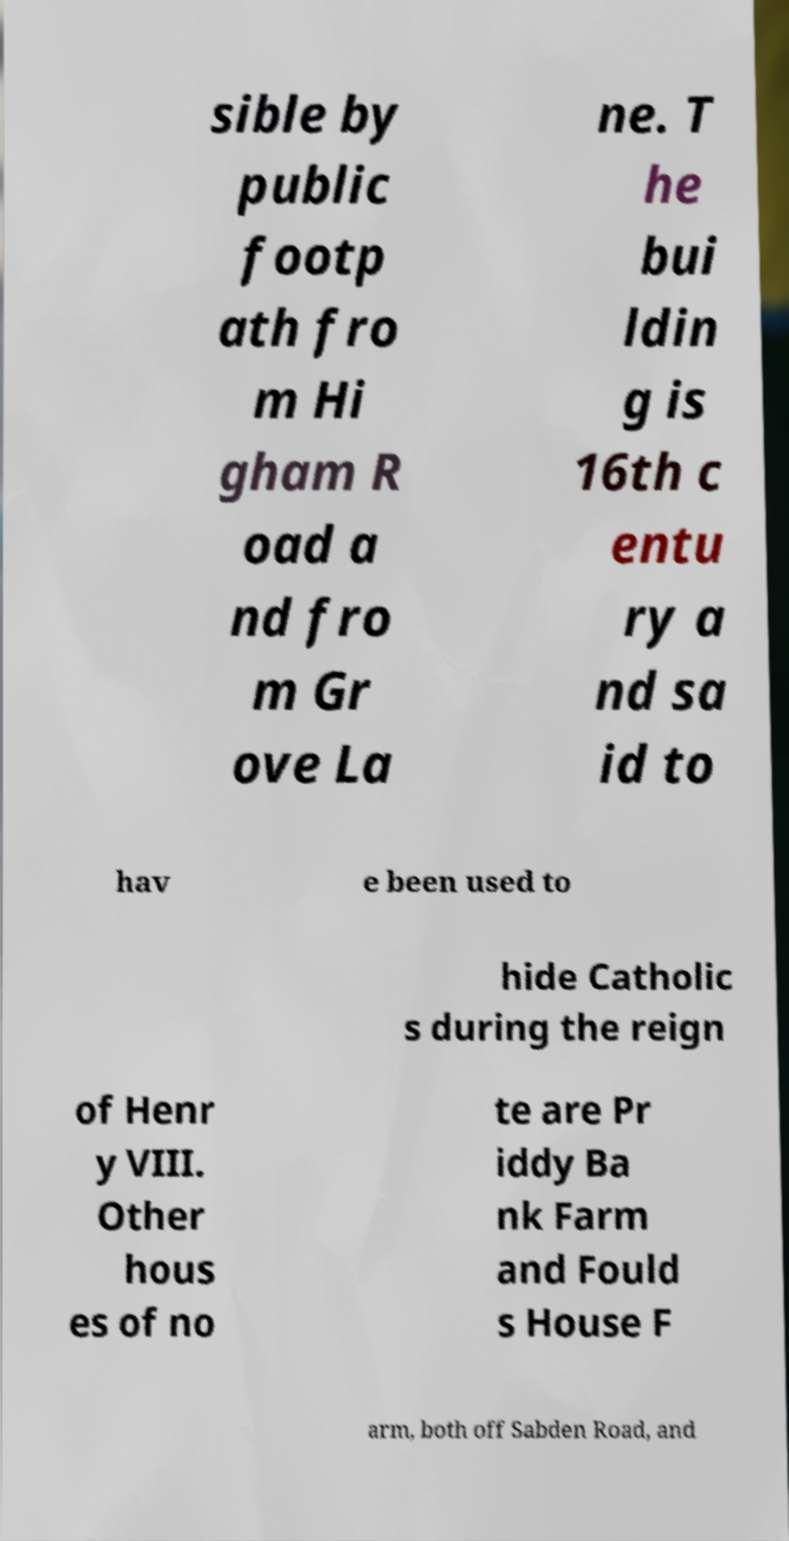What messages or text are displayed in this image? I need them in a readable, typed format. sible by public footp ath fro m Hi gham R oad a nd fro m Gr ove La ne. T he bui ldin g is 16th c entu ry a nd sa id to hav e been used to hide Catholic s during the reign of Henr y VIII. Other hous es of no te are Pr iddy Ba nk Farm and Fould s House F arm, both off Sabden Road, and 